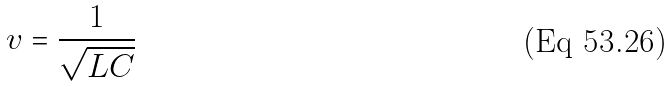<formula> <loc_0><loc_0><loc_500><loc_500>v = \frac { 1 } { \sqrt { L C } }</formula> 